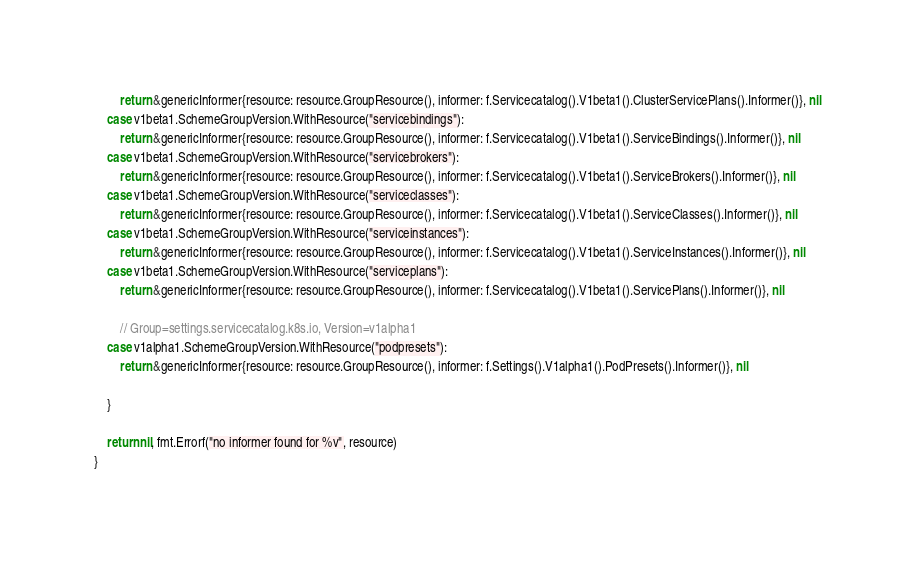<code> <loc_0><loc_0><loc_500><loc_500><_Go_>		return &genericInformer{resource: resource.GroupResource(), informer: f.Servicecatalog().V1beta1().ClusterServicePlans().Informer()}, nil
	case v1beta1.SchemeGroupVersion.WithResource("servicebindings"):
		return &genericInformer{resource: resource.GroupResource(), informer: f.Servicecatalog().V1beta1().ServiceBindings().Informer()}, nil
	case v1beta1.SchemeGroupVersion.WithResource("servicebrokers"):
		return &genericInformer{resource: resource.GroupResource(), informer: f.Servicecatalog().V1beta1().ServiceBrokers().Informer()}, nil
	case v1beta1.SchemeGroupVersion.WithResource("serviceclasses"):
		return &genericInformer{resource: resource.GroupResource(), informer: f.Servicecatalog().V1beta1().ServiceClasses().Informer()}, nil
	case v1beta1.SchemeGroupVersion.WithResource("serviceinstances"):
		return &genericInformer{resource: resource.GroupResource(), informer: f.Servicecatalog().V1beta1().ServiceInstances().Informer()}, nil
	case v1beta1.SchemeGroupVersion.WithResource("serviceplans"):
		return &genericInformer{resource: resource.GroupResource(), informer: f.Servicecatalog().V1beta1().ServicePlans().Informer()}, nil

		// Group=settings.servicecatalog.k8s.io, Version=v1alpha1
	case v1alpha1.SchemeGroupVersion.WithResource("podpresets"):
		return &genericInformer{resource: resource.GroupResource(), informer: f.Settings().V1alpha1().PodPresets().Informer()}, nil

	}

	return nil, fmt.Errorf("no informer found for %v", resource)
}
</code> 